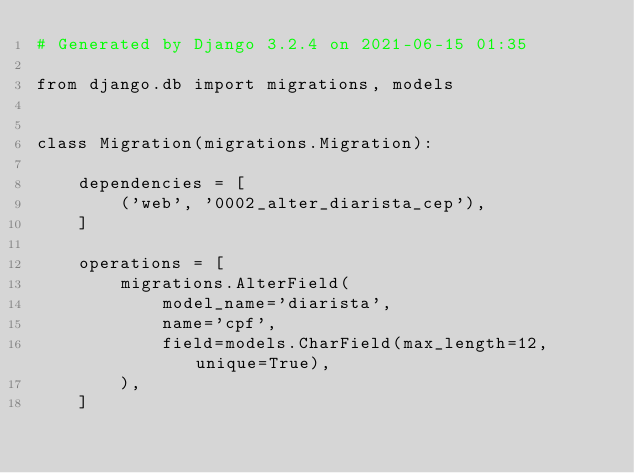<code> <loc_0><loc_0><loc_500><loc_500><_Python_># Generated by Django 3.2.4 on 2021-06-15 01:35

from django.db import migrations, models


class Migration(migrations.Migration):

    dependencies = [
        ('web', '0002_alter_diarista_cep'),
    ]

    operations = [
        migrations.AlterField(
            model_name='diarista',
            name='cpf',
            field=models.CharField(max_length=12, unique=True),
        ),
    ]
</code> 